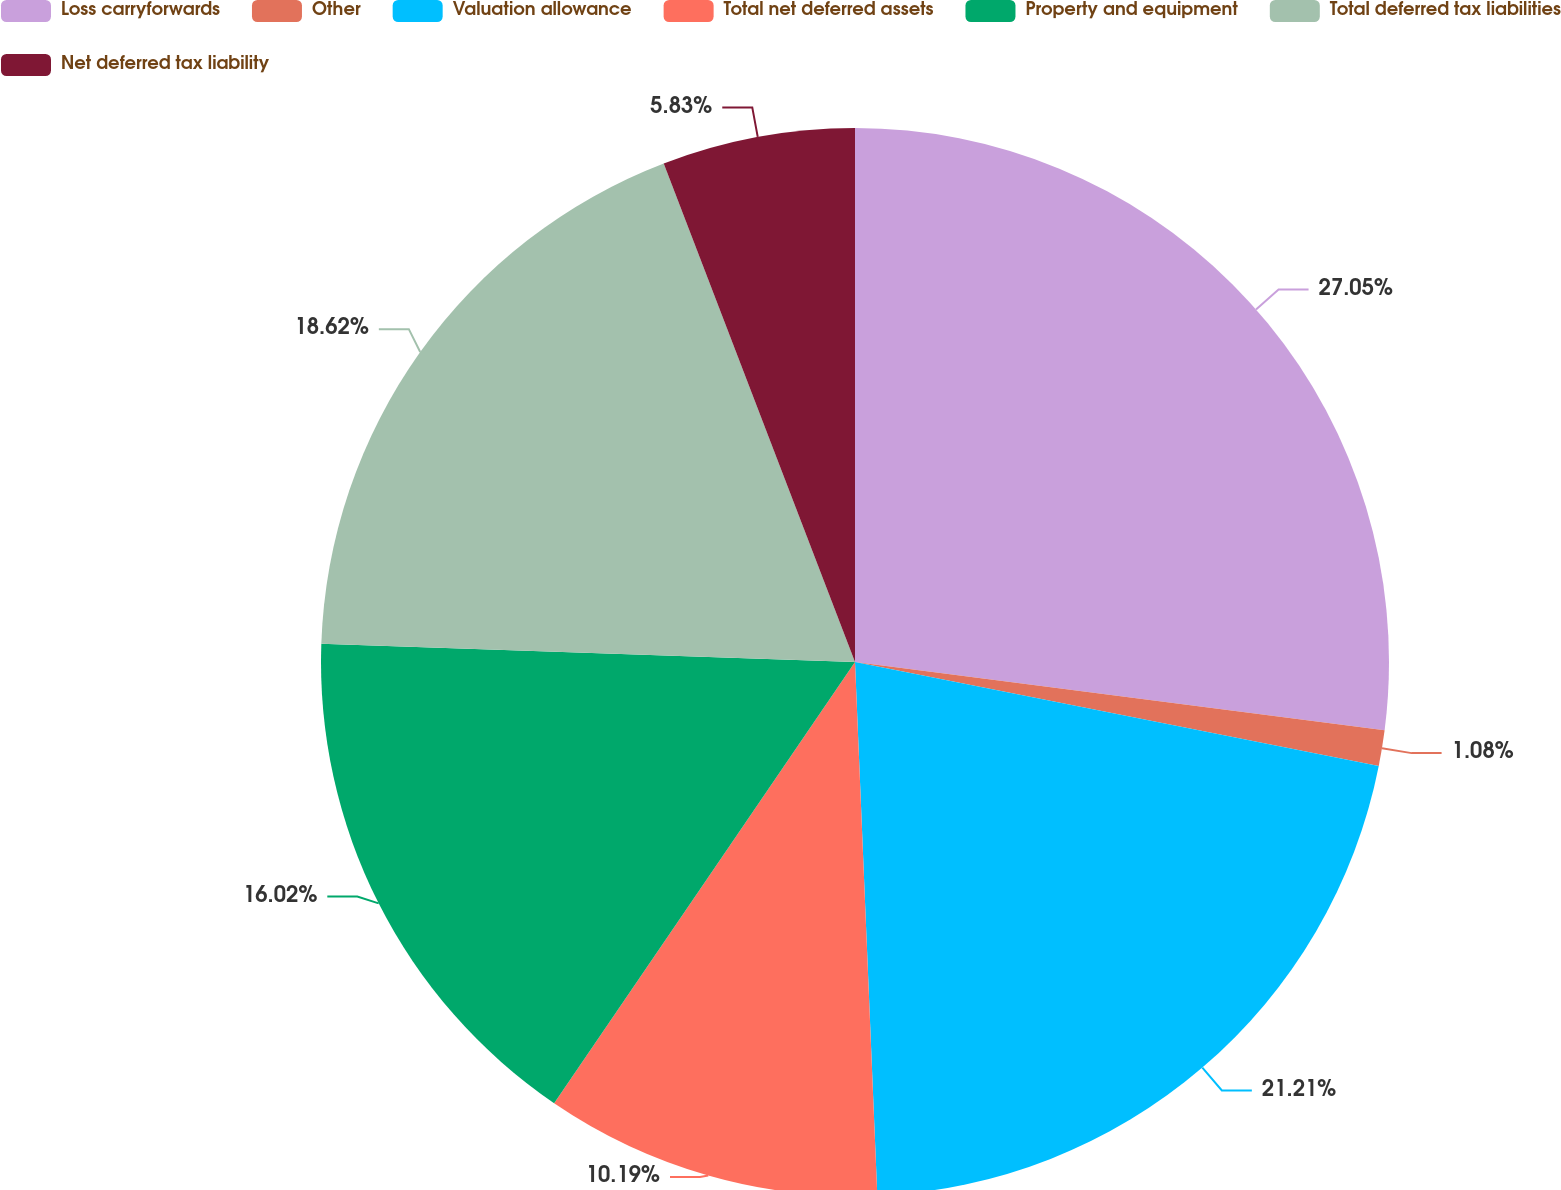<chart> <loc_0><loc_0><loc_500><loc_500><pie_chart><fcel>Loss carryforwards<fcel>Other<fcel>Valuation allowance<fcel>Total net deferred assets<fcel>Property and equipment<fcel>Total deferred tax liabilities<fcel>Net deferred tax liability<nl><fcel>27.04%<fcel>1.08%<fcel>21.21%<fcel>10.19%<fcel>16.02%<fcel>18.62%<fcel>5.83%<nl></chart> 